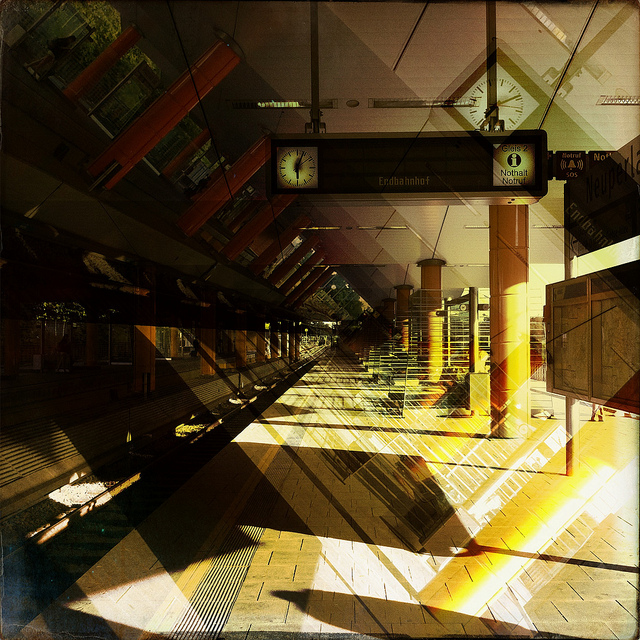Please transcribe the text in this image. Nothait Notru rl No i 